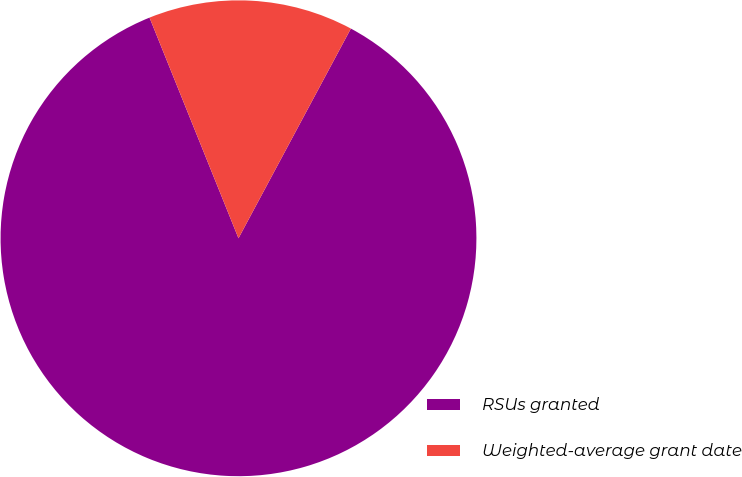Convert chart. <chart><loc_0><loc_0><loc_500><loc_500><pie_chart><fcel>RSUs granted<fcel>Weighted-average grant date<nl><fcel>86.07%<fcel>13.93%<nl></chart> 